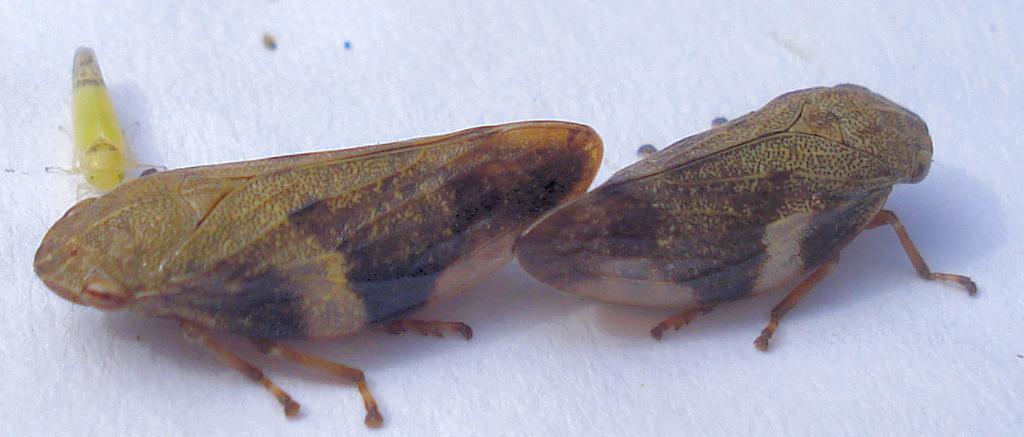In one or two sentences, can you explain what this image depicts? In the image we can see some insects. 